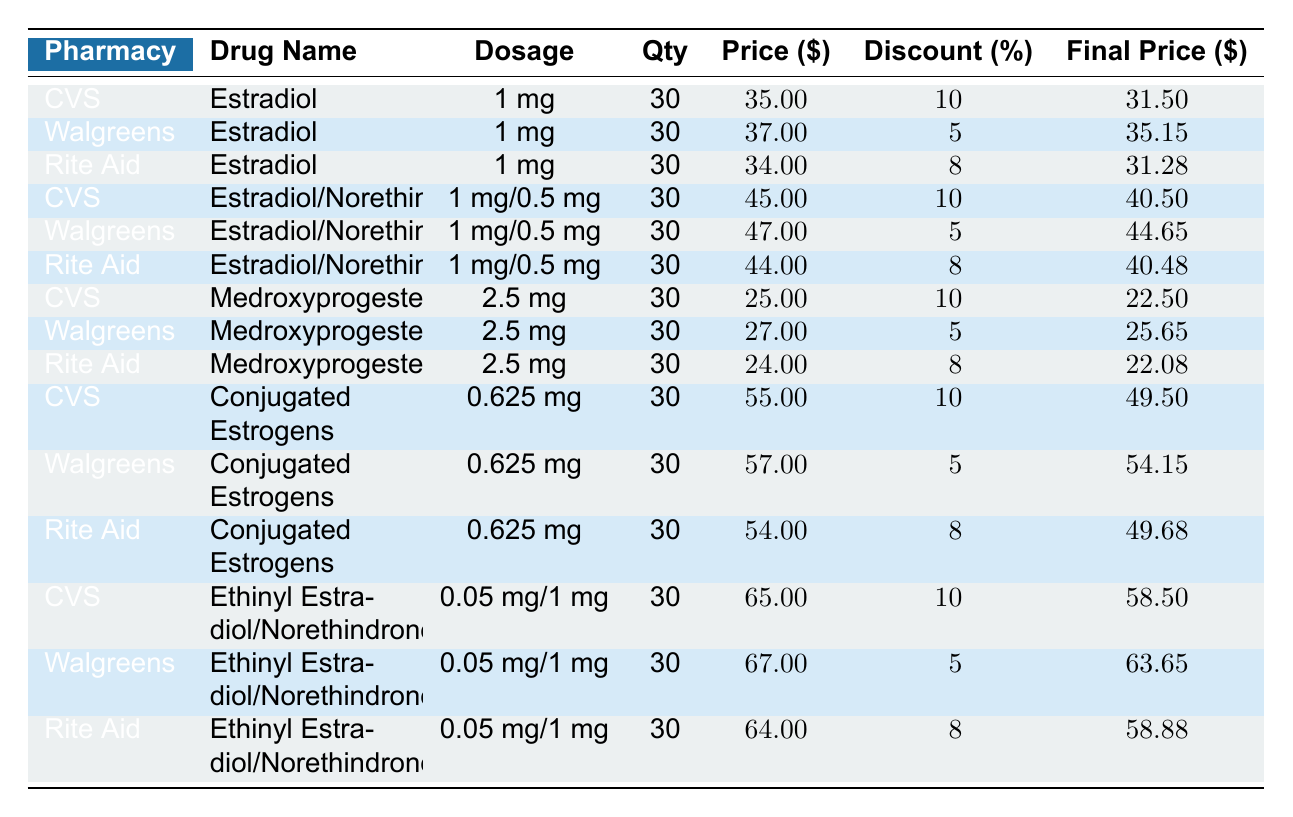What is the final price of Estradiol at CVS Pharmacy? The final price for Estradiol at CVS Pharmacy is listed in the table under the "Final Price ($)" column and corresponds to the row containing CVS Pharmacy and Estradiol. This value is 31.50.
Answer: 31.50 Which pharmacy offers the lowest final price for Medroxyprogesterone? Reviewing the final prices for Medroxyprogesterone across all pharmacies, CVS offers 22.50, Walgreens offers 25.65, and Rite Aid offers 22.08. The lowest final price is at Rite Aid.
Answer: Rite Aid What is the average final price for Estradiol/Norethindrone across the three pharmacies? The final prices for Estradiol/Norethindrone are: CVS - 40.50, Walgreens - 44.65, and Rite Aid - 40.48. Summing these gives 40.50 + 44.65 + 40.48 = 125.63. To find the average, divide by the number of pharmacies (3): 125.63 / 3 = 41.88.
Answer: 41.88 Is the discount percentage for Estradiol at Walgreens greater than 5%? The discount percentage for Estradiol at Walgreens is 5%, which is not greater than 5%. Therefore, the answer is false.
Answer: No Which pharmacy provides Conjugated Estrogens at a higher final price than Walgreens? According to the table, Walgreens' final price for Conjugated Estrogens is 54.15. In the first row for CVS, the final price is 49.50, and Rite Aid's final price is 49.68. Both CVS and Rite Aid have lower final prices than Walgreens, indicating that no pharmacy offers higher final pricing than Walgreens.
Answer: None 